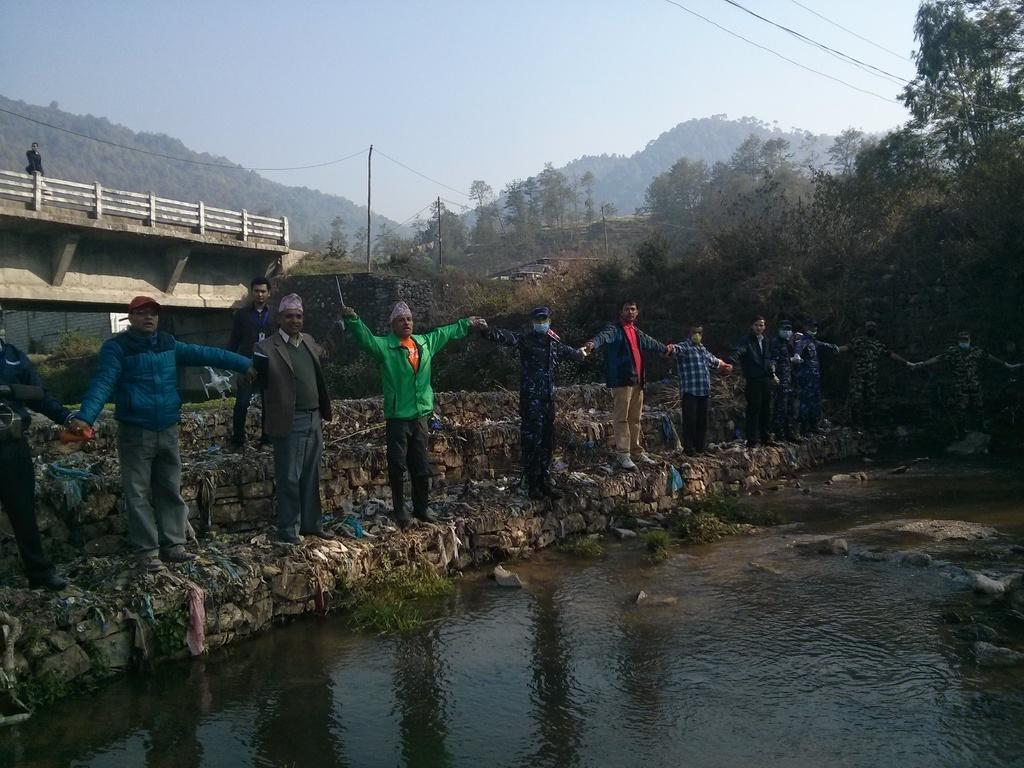How would you summarize this image in a sentence or two? In this picture we can see the group of men holding there hands standing on the small granite wall and giving the pose. In the front bottom side we can see the water pound. Behind there is a bridge and many trees. 